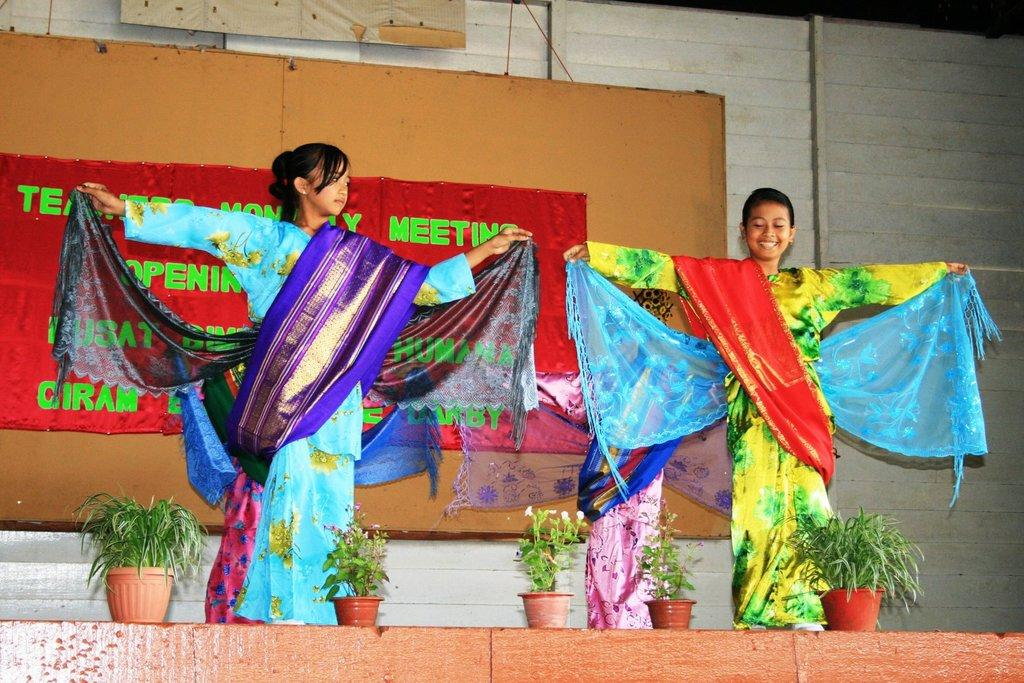How many people are dancing in the image? There are four persons dancing in the image. Where is the dancing taking place? The dancing is taking place on a dais. What can be seen at the bottom of the image? There are potted plants at the bottom of the image. What is present on the wall in the background of the image? There is a banner fixed on the wall in the background of the image. What type of van can be seen parked near the cemetery in the image? There is no van or cemetery present in the image; it features four persons dancing on a dais with potted plants and a banner on the wall. What valuable jewel is being worn by the dancers in the image? There is no mention of any jewels being worn by the dancers in the image. 